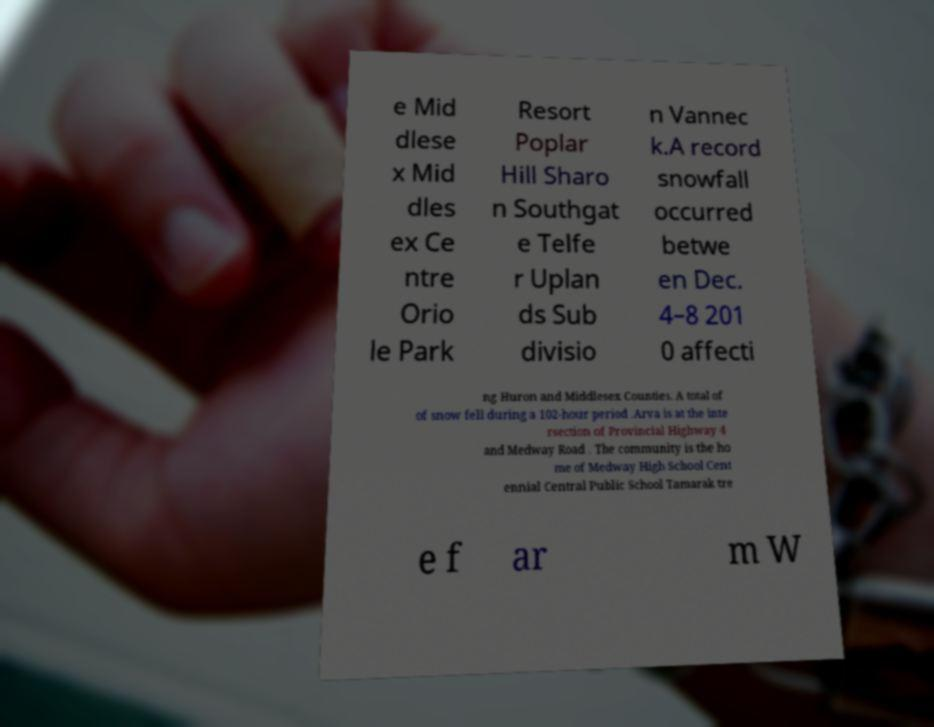Please identify and transcribe the text found in this image. e Mid dlese x Mid dles ex Ce ntre Orio le Park Resort Poplar Hill Sharo n Southgat e Telfe r Uplan ds Sub divisio n Vannec k.A record snowfall occurred betwe en Dec. 4–8 201 0 affecti ng Huron and Middlesex Counties. A total of of snow fell during a 102-hour period .Arva is at the inte rsection of Provincial Highway 4 and Medway Road . The community is the ho me of Medway High School Cent ennial Central Public School Tamarak tre e f ar m W 